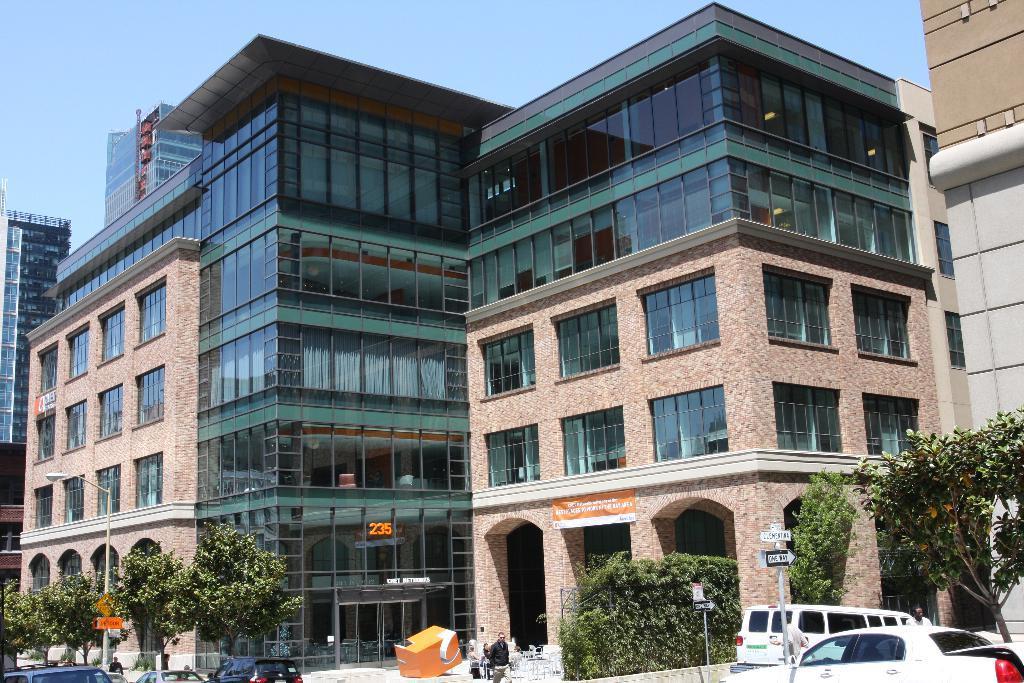In one or two sentences, can you explain what this image depicts? There are people, trees, vehicles and poles in the foreground area of the image, there are buildings and the sky in the background. 